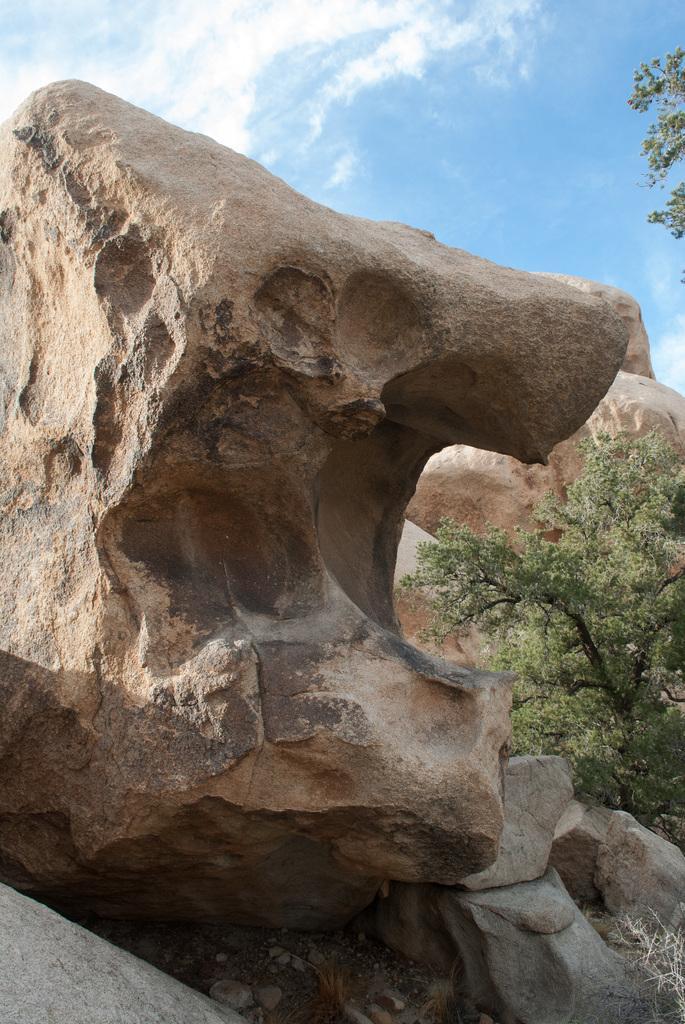Could you give a brief overview of what you see in this image? In this image there are rocks, trees. In the background of the image there is sky. 